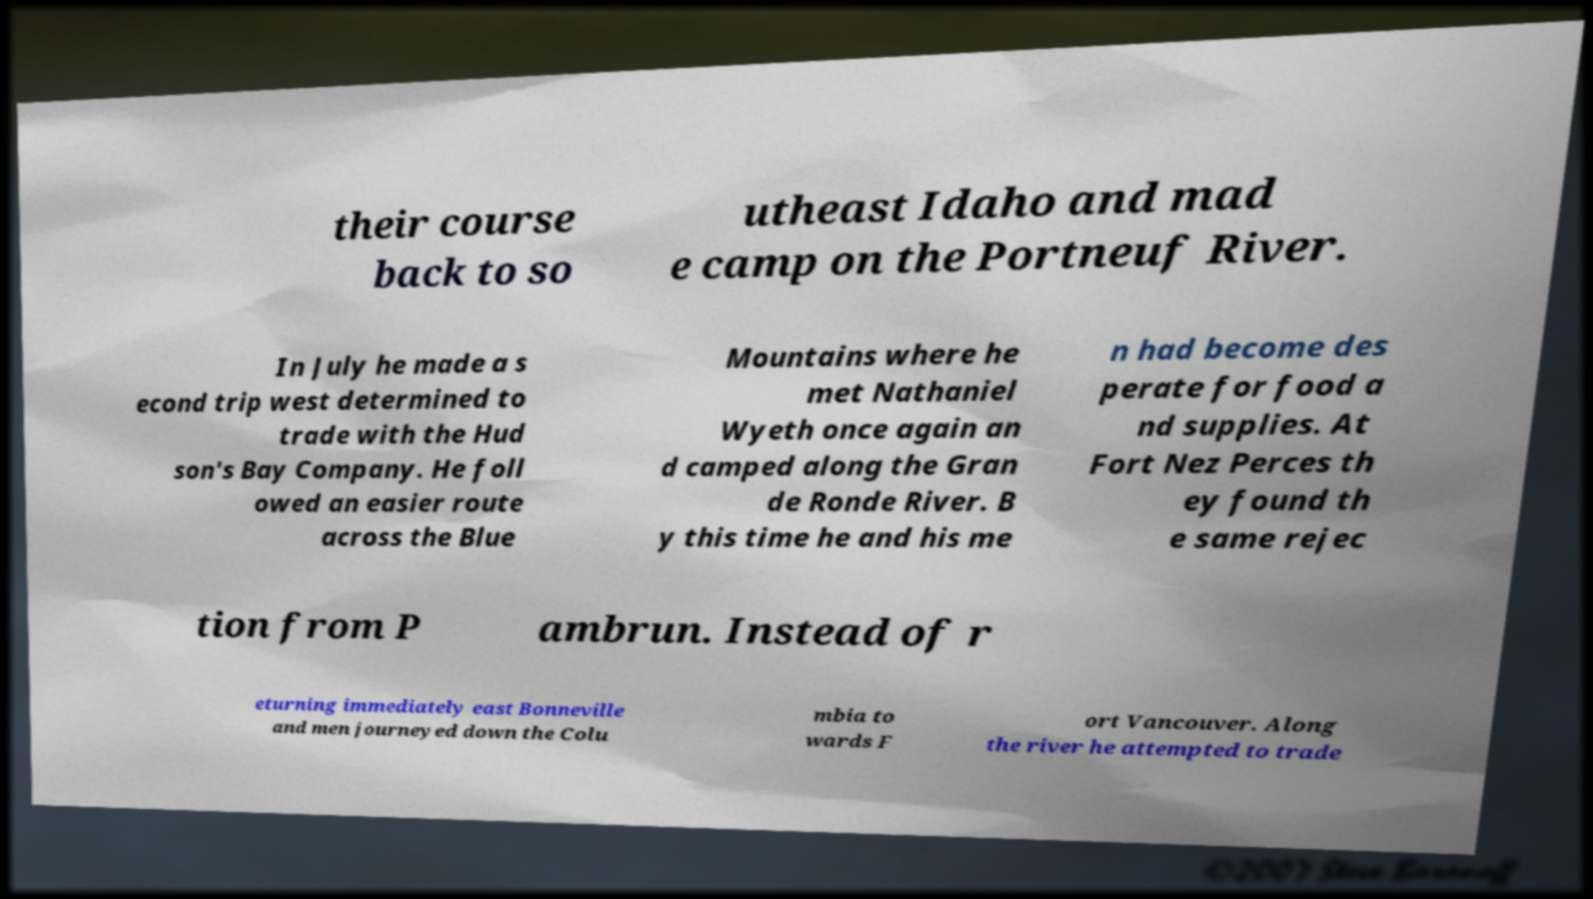Can you accurately transcribe the text from the provided image for me? their course back to so utheast Idaho and mad e camp on the Portneuf River. In July he made a s econd trip west determined to trade with the Hud son's Bay Company. He foll owed an easier route across the Blue Mountains where he met Nathaniel Wyeth once again an d camped along the Gran de Ronde River. B y this time he and his me n had become des perate for food a nd supplies. At Fort Nez Perces th ey found th e same rejec tion from P ambrun. Instead of r eturning immediately east Bonneville and men journeyed down the Colu mbia to wards F ort Vancouver. Along the river he attempted to trade 